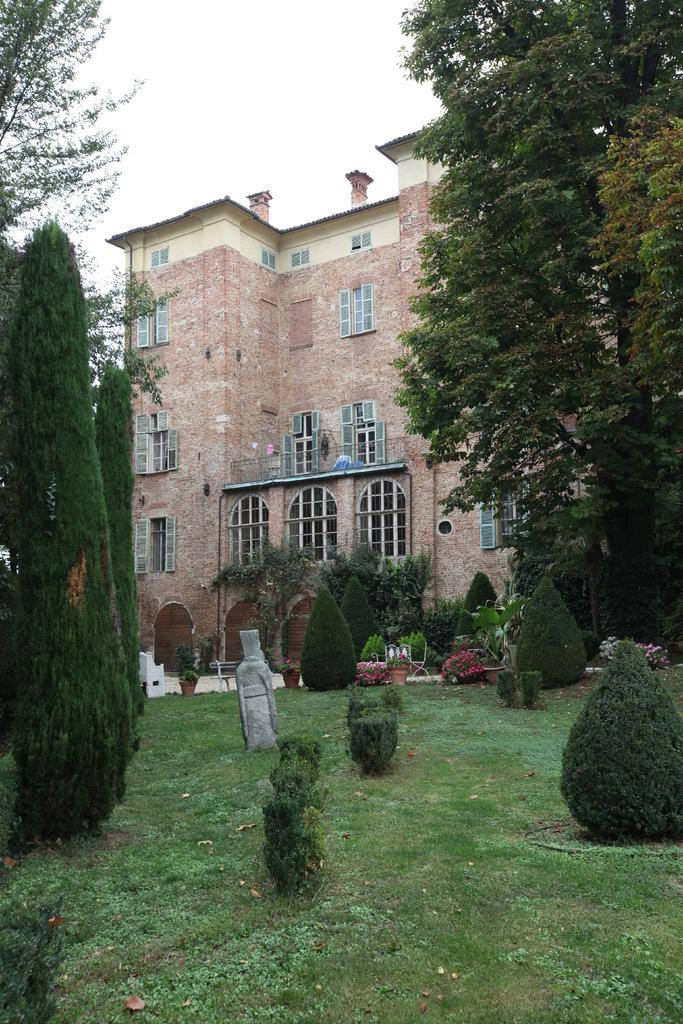What type of structure is in the image? There is a building in the image. What can be seen at the bottom of the image? Plants and grass are visible at the bottom of the image. What type of vegetation is present on the sides of the image? Trees are present on the right and left sides of the image. What is visible at the top of the image? The sky is visible at the top of the image. What can be observed in the sky? Clouds are present in the sky. What hobbies does the dog have in the image? There is no dog present in the image, so it is not possible to discuss its hobbies. 